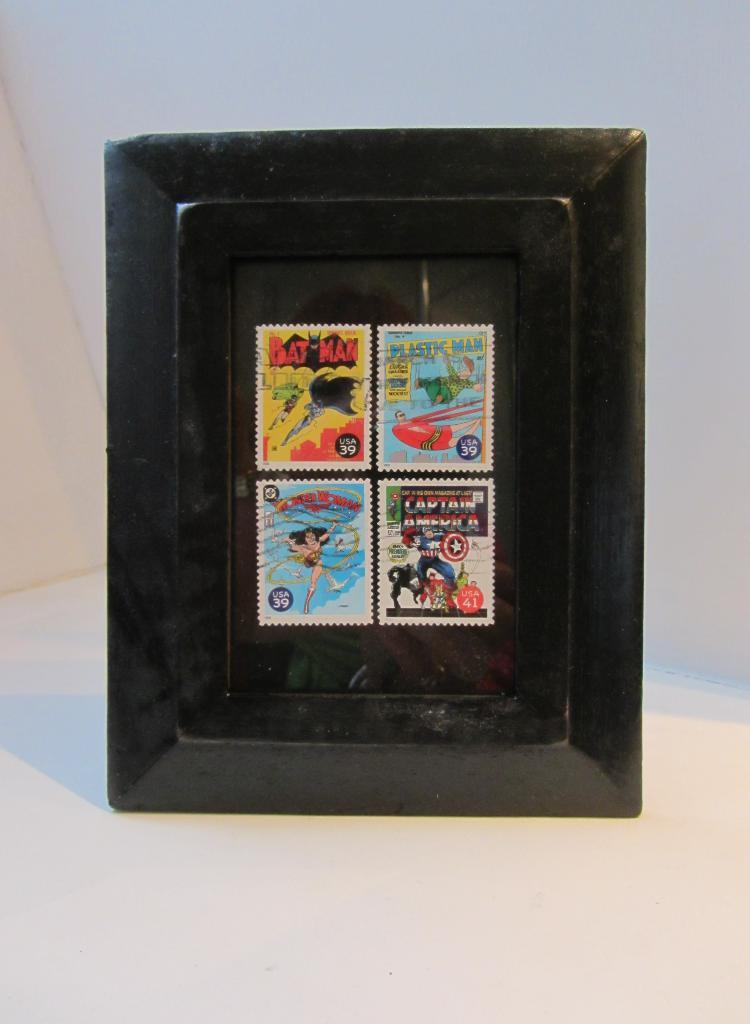<image>
Give a short and clear explanation of the subsequent image. Four postage stamps show different superheros, including Bat Man. 